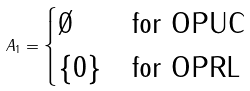Convert formula to latex. <formula><loc_0><loc_0><loc_500><loc_500>A _ { 1 } = \begin{cases} \emptyset & \text {for OPUC} \\ \{ 0 \} & \text {for OPRL} \end{cases}</formula> 